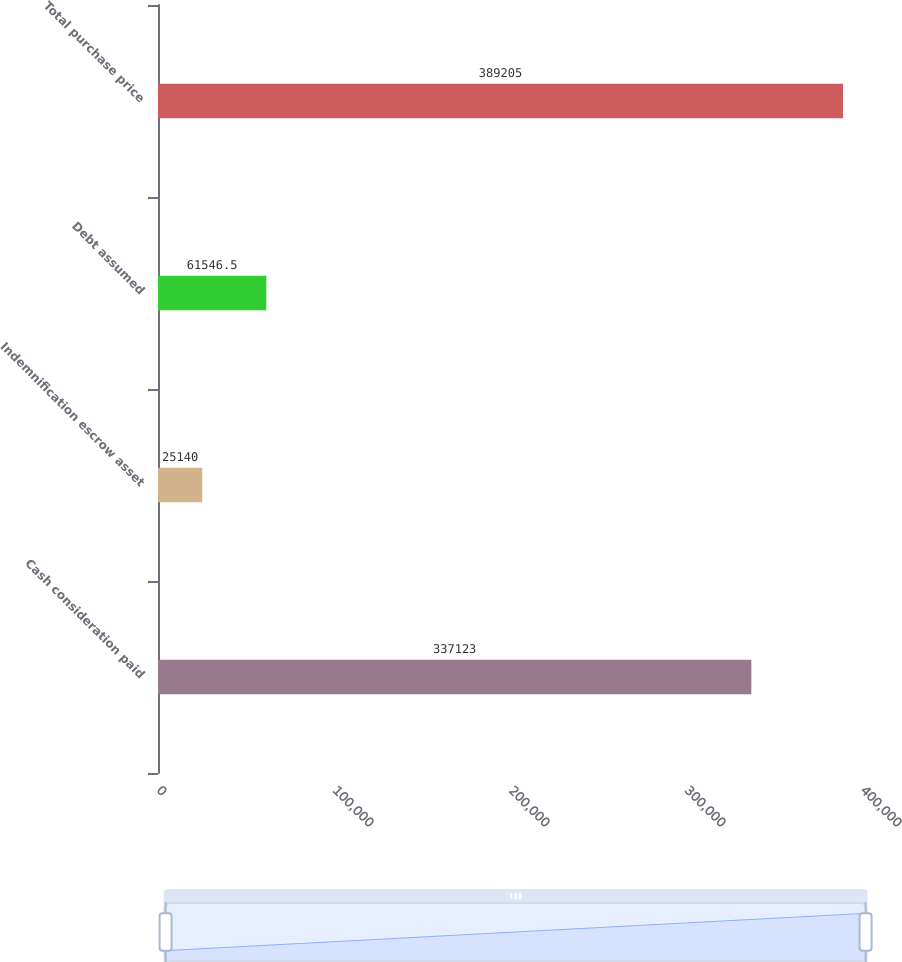Convert chart. <chart><loc_0><loc_0><loc_500><loc_500><bar_chart><fcel>Cash consideration paid<fcel>Indemnification escrow asset<fcel>Debt assumed<fcel>Total purchase price<nl><fcel>337123<fcel>25140<fcel>61546.5<fcel>389205<nl></chart> 